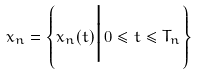<formula> <loc_0><loc_0><loc_500><loc_500>x _ { n } = \left \{ x _ { n } ( t ) \Big | \, 0 \leq t \leq T _ { n } \right \}</formula> 